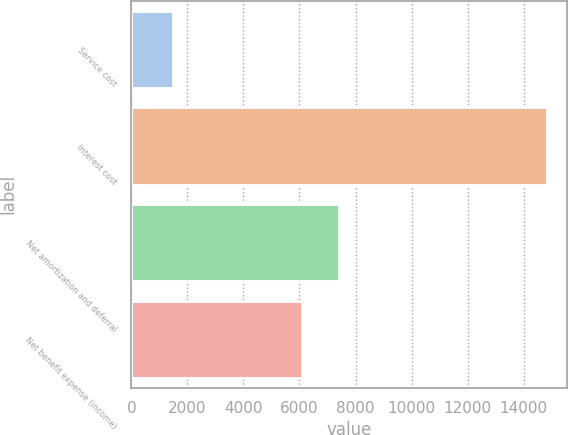Convert chart. <chart><loc_0><loc_0><loc_500><loc_500><bar_chart><fcel>Service cost<fcel>Interest cost<fcel>Net amortization and deferral<fcel>Net benefit expense (income)<nl><fcel>1500<fcel>14816<fcel>7418.6<fcel>6087<nl></chart> 